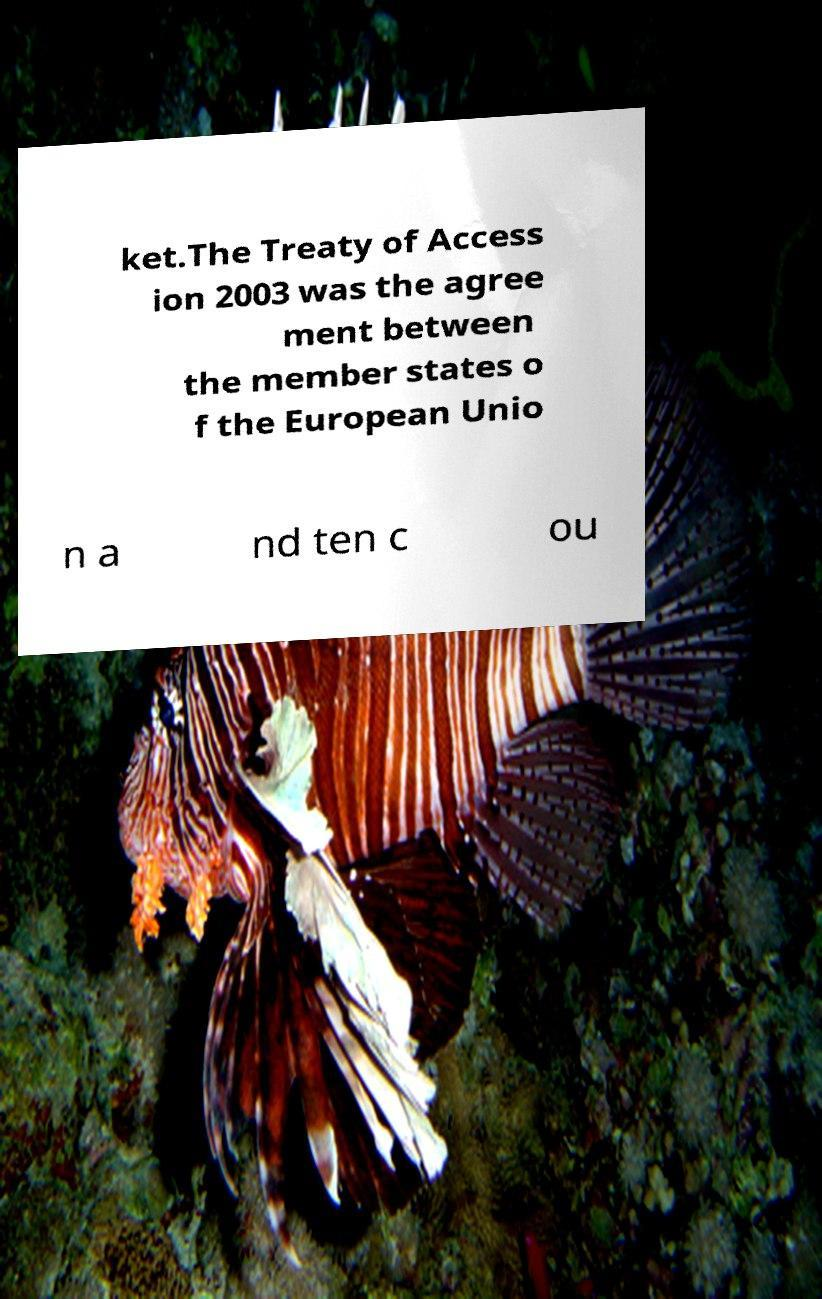Could you assist in decoding the text presented in this image and type it out clearly? ket.The Treaty of Access ion 2003 was the agree ment between the member states o f the European Unio n a nd ten c ou 